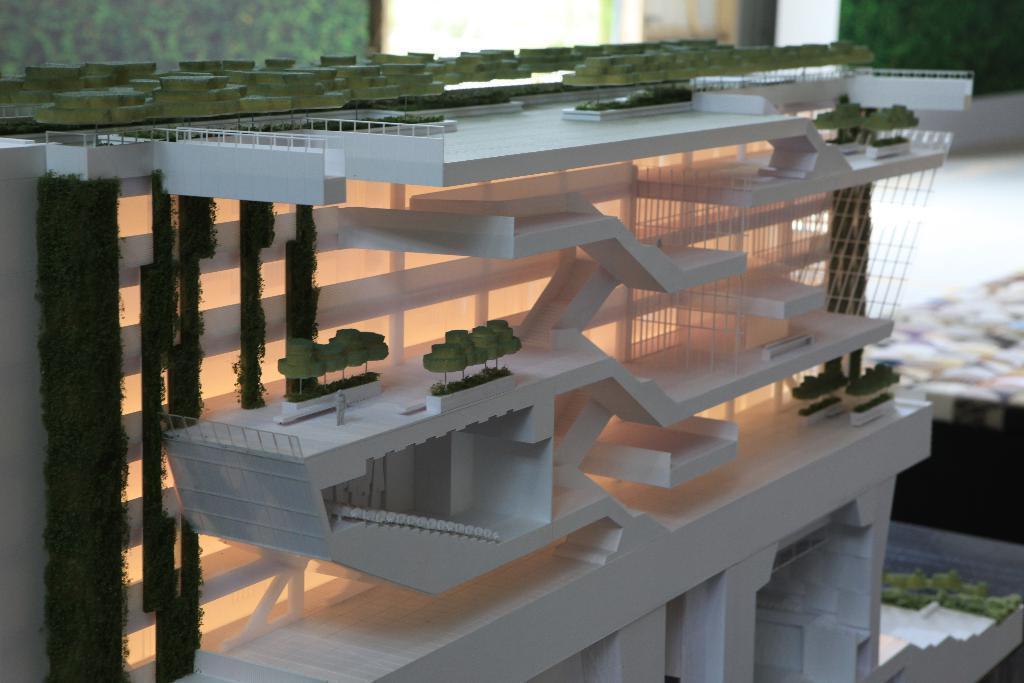Please provide a concise description of this image. In this image we can see there is a project of the building kept on a table beside that there are so many walls. 